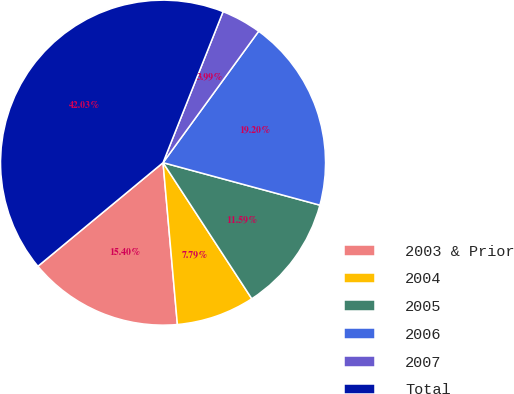Convert chart. <chart><loc_0><loc_0><loc_500><loc_500><pie_chart><fcel>2003 & Prior<fcel>2004<fcel>2005<fcel>2006<fcel>2007<fcel>Total<nl><fcel>15.4%<fcel>7.79%<fcel>11.59%<fcel>19.2%<fcel>3.99%<fcel>42.03%<nl></chart> 